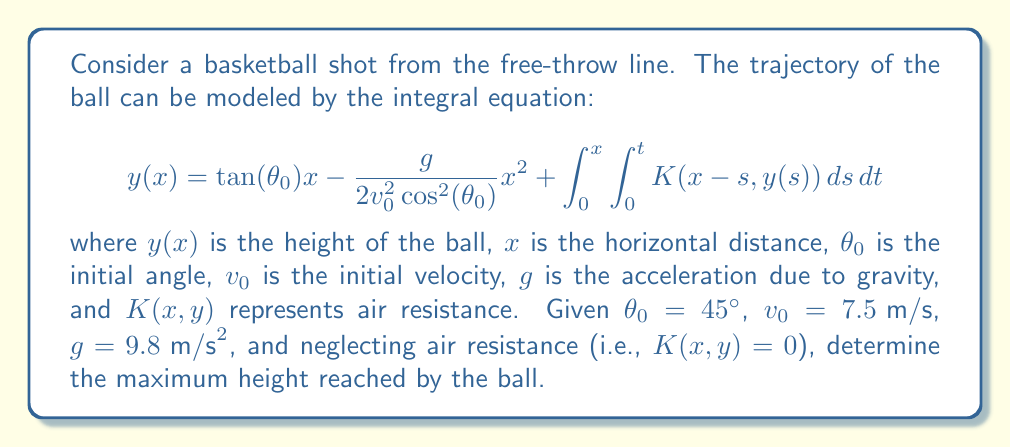Can you answer this question? Let's approach this step-by-step:

1) First, we simplify the equation by neglecting air resistance:

   $$y(x) = \tan(\theta_0)x - \frac{g}{2v_0^2\cos^2(\theta_0)}x^2$$

2) We're given $\theta_0 = 45°$. Note that $\tan(45°) = 1$ and $\cos(45°) = \frac{1}{\sqrt{2}}$:

   $$y(x) = x - \frac{9.8}{2(7.5)^2(\frac{1}{\sqrt{2}})^2}x^2$$

3) Simplify the coefficient of $x^2$:

   $$y(x) = x - \frac{9.8}{2(7.5)^2(\frac{1}{2})}x^2 = x - \frac{9.8}{56.25}x^2$$

4) To find the maximum height, we need to find where $\frac{dy}{dx} = 0$:

   $$\frac{dy}{dx} = 1 - 2(\frac{9.8}{56.25})x$$

5) Set this equal to zero and solve for x:

   $$1 - 2(\frac{9.8}{56.25})x = 0$$
   $$2(\frac{9.8}{56.25})x = 1$$
   $$x = \frac{56.25}{2(9.8)} \approx 2.87 \text{ m}$$

6) This x-value represents the horizontal distance at which the ball reaches its maximum height. To find the maximum height, we plug this x-value back into our original equation:

   $$y(2.87) = 2.87 - \frac{9.8}{56.25}(2.87)^2 \approx 1.43 \text{ m}$$

Therefore, the maximum height reached by the ball is approximately 1.43 meters.
Answer: $1.43 \text{ m}$ 